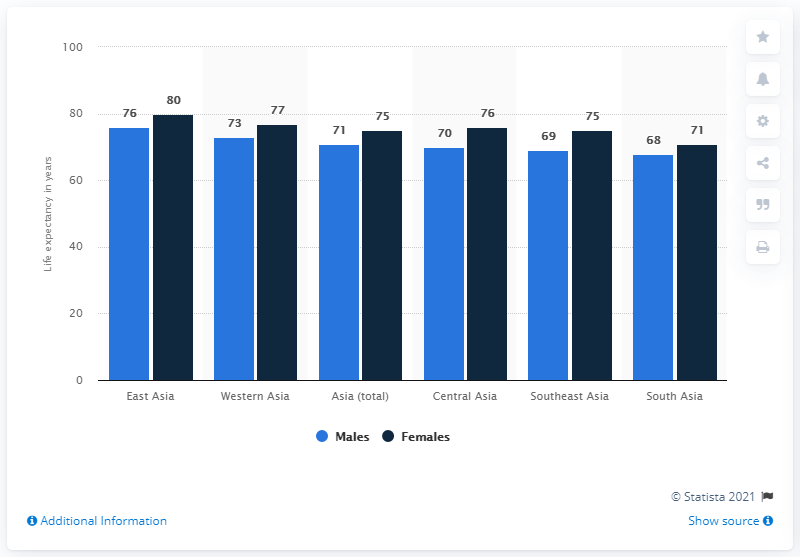What is the life expectancy trend for males across the regions shown in the graph? The life expectancy for males shows a variation across the regions. Western Asia has the highest male life expectancy at 80 years, closely followed by East Asia at 76 years. South Asia shows the lowest at 68 years, underlining the disparities in health outcomes across these regions. 